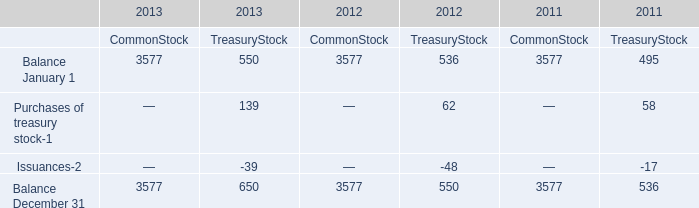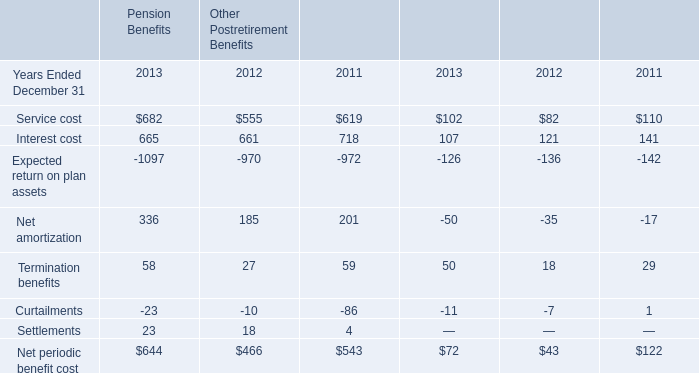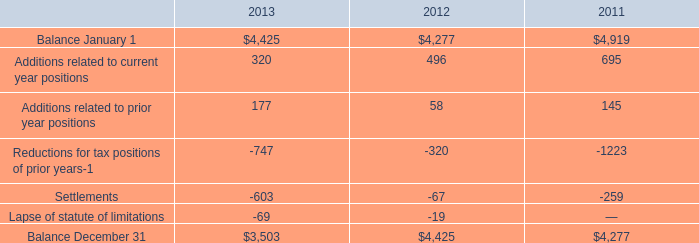what was the percentual decrease observed in the liabilities for accrued interest and penalties during 2012 and 2013? 
Computations: ((665 - (1.2 * 1000)) / (1.2 * 1000))
Answer: -0.44583. 